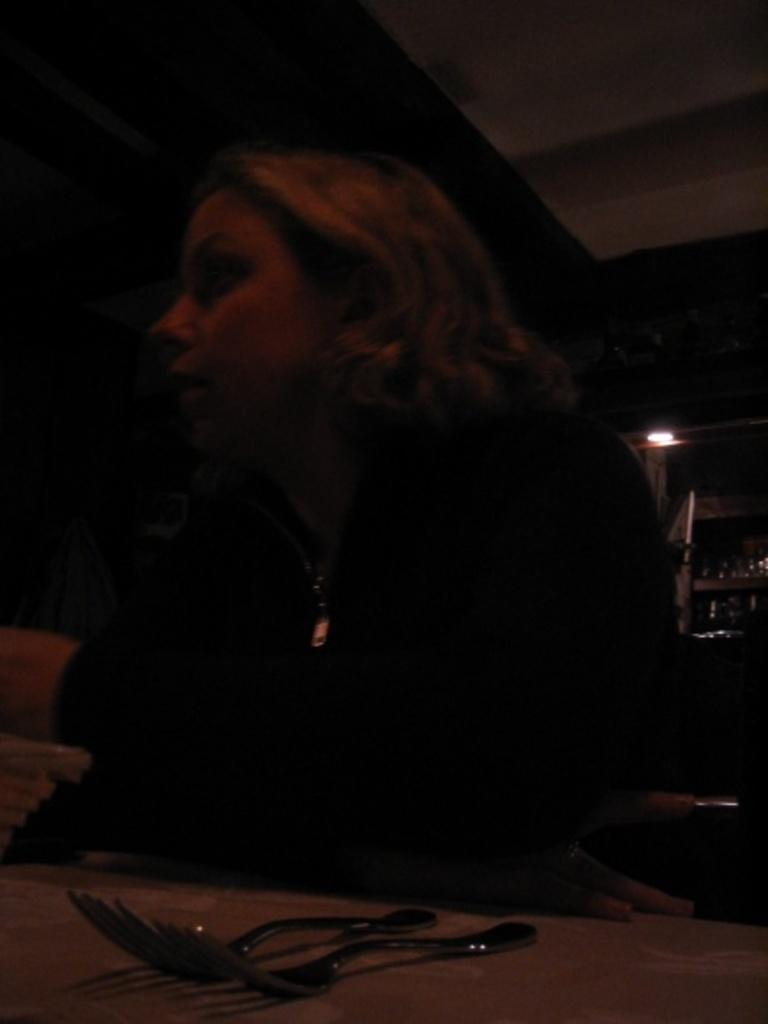What piece of furniture is present in the image? There is a table in the image. What is the woman doing in the image? A woman is sitting on the table. How many forks can be seen in the image? There are two forks in the image. What type of illumination is present in the image? There is a light in the image. What type of containers are visible in the image? There are bottles in the image. What type of sea creatures can be seen swimming in the image? There are no sea creatures present in the image; it does not depict a marine environment. 